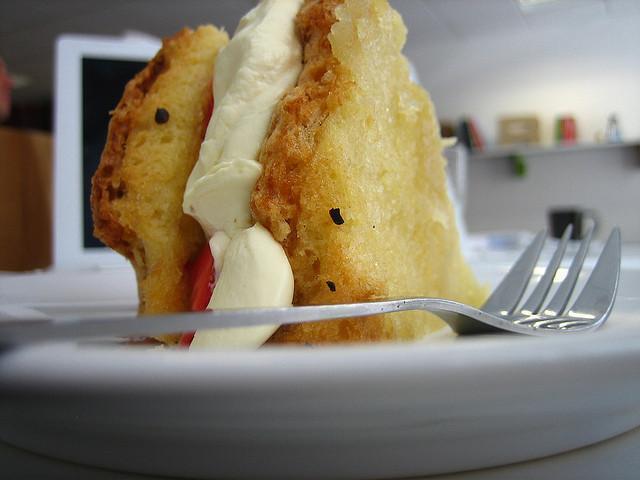What type of fork is included with the meal?
Answer the question by selecting the correct answer among the 4 following choices and explain your choice with a short sentence. The answer should be formatted with the following format: `Answer: choice
Rationale: rationale.`
Options: Dessert, fruit, baby, salad. Answer: dessert.
Rationale: The fork is for dessert. 